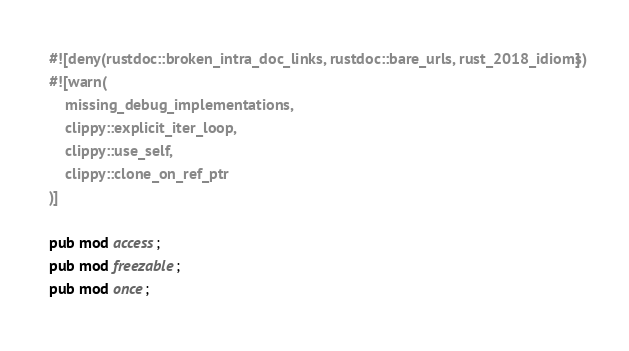<code> <loc_0><loc_0><loc_500><loc_500><_Rust_>#![deny(rustdoc::broken_intra_doc_links, rustdoc::bare_urls, rust_2018_idioms)]
#![warn(
    missing_debug_implementations,
    clippy::explicit_iter_loop,
    clippy::use_self,
    clippy::clone_on_ref_ptr
)]

pub mod access;
pub mod freezable;
pub mod once;
</code> 